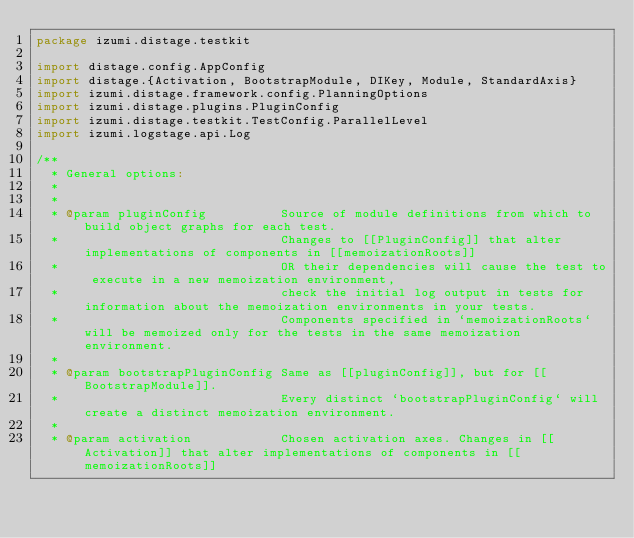<code> <loc_0><loc_0><loc_500><loc_500><_Scala_>package izumi.distage.testkit

import distage.config.AppConfig
import distage.{Activation, BootstrapModule, DIKey, Module, StandardAxis}
import izumi.distage.framework.config.PlanningOptions
import izumi.distage.plugins.PluginConfig
import izumi.distage.testkit.TestConfig.ParallelLevel
import izumi.logstage.api.Log

/**
  * General options:
  *
  *
  * @param pluginConfig          Source of module definitions from which to build object graphs for each test.
  *                              Changes to [[PluginConfig]] that alter implementations of components in [[memoizationRoots]]
  *                              OR their dependencies will cause the test to execute in a new memoization environment,
  *                              check the initial log output in tests for information about the memoization environments in your tests.
  *                              Components specified in `memoizationRoots` will be memoized only for the tests in the same memoization environment.
  *
  * @param bootstrapPluginConfig Same as [[pluginConfig]], but for [[BootstrapModule]].
  *                              Every distinct `bootstrapPluginConfig` will create a distinct memoization environment.
  *
  * @param activation            Chosen activation axes. Changes in [[Activation]] that alter implementations of components in [[memoizationRoots]]</code> 